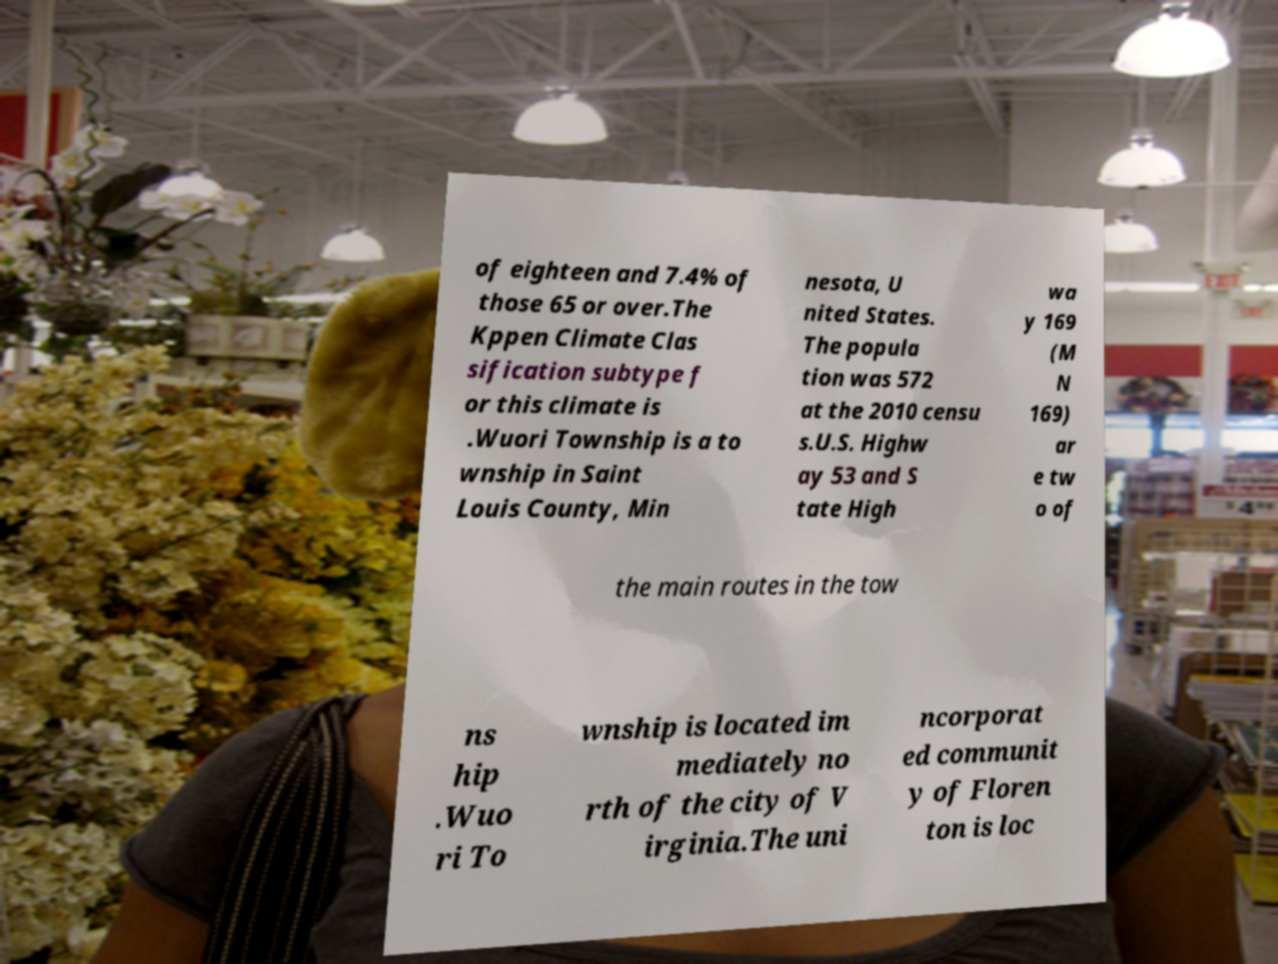Please identify and transcribe the text found in this image. of eighteen and 7.4% of those 65 or over.The Kppen Climate Clas sification subtype f or this climate is .Wuori Township is a to wnship in Saint Louis County, Min nesota, U nited States. The popula tion was 572 at the 2010 censu s.U.S. Highw ay 53 and S tate High wa y 169 (M N 169) ar e tw o of the main routes in the tow ns hip .Wuo ri To wnship is located im mediately no rth of the city of V irginia.The uni ncorporat ed communit y of Floren ton is loc 